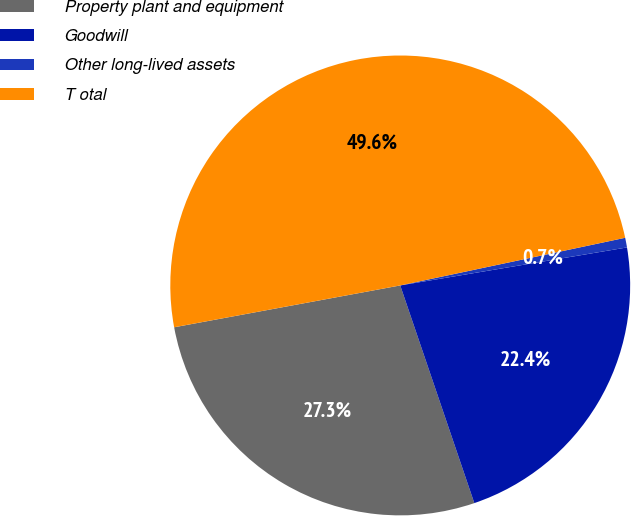<chart> <loc_0><loc_0><loc_500><loc_500><pie_chart><fcel>Property plant and equipment<fcel>Goodwill<fcel>Other long-lived assets<fcel>T otal<nl><fcel>27.31%<fcel>22.42%<fcel>0.68%<fcel>49.59%<nl></chart> 